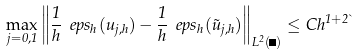Convert formula to latex. <formula><loc_0><loc_0><loc_500><loc_500>\max _ { j = 0 , 1 } \left \| \frac { 1 } { h } \ e p s _ { h } ( u _ { j , h } ) - \frac { 1 } { h } \ e p s _ { h } ( \tilde { u } _ { j , h } ) \right \| _ { L ^ { 2 } ( \Omega ) } \leq C h ^ { 1 + 2 \theta }</formula> 